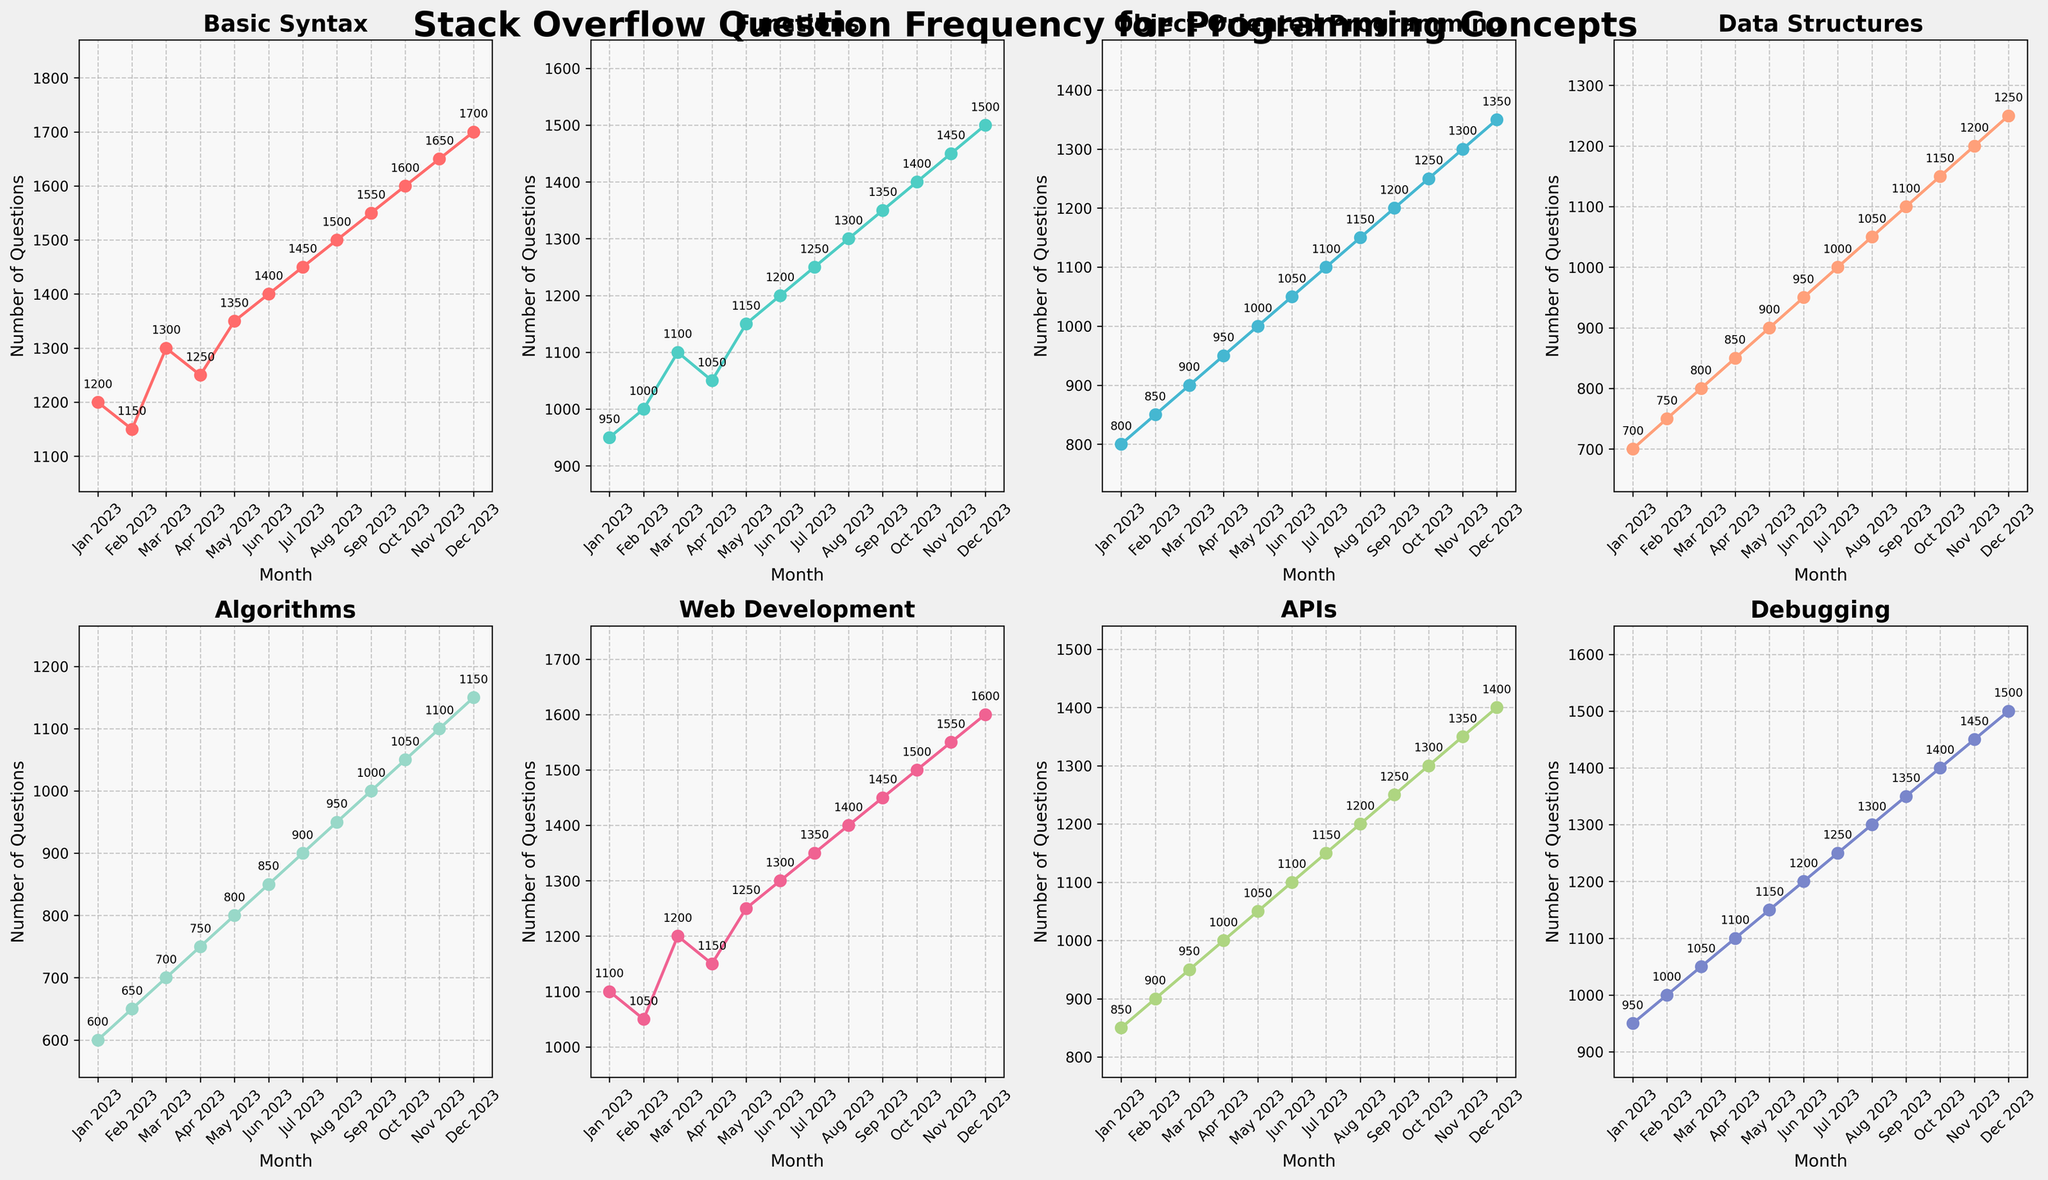What is the total number of questions for 'Web Development' in the first half of 2023? Sum the number of questions for 'Web Development' from Jan 2023 to Jun 2023: 1100 + 1050 + 1200 + 1150 + 1250 + 1300. The total is 7150.
Answer: 7150 In which month did 'Basic Syntax' receive the highest number of questions? The highest number of questions for 'Basic Syntax' is 1700 in December 2023.
Answer: December 2023 Compare the number of questions for 'Algorithms' in April and October 2023. Which month had more questions? 'Algorithms' had 750 questions in April and 1050 questions in October. October had more questions.
Answer: October What is the average number of questions per month for 'Functions' in the second half of 2023? Sum the number of questions for 'Functions' from Jul 2023 to Dec 2023: 1250 + 1300 + 1350 + 1400 + 1450 + 1500. The total is 8250. Divide by the number of months (6) to get the average: 8250/6 = 1375.
Answer: 1375 For 'Data Structures', what is the difference in the number of questions between the peak month and the lowest month in 2023? The highest number of questions for 'Data Structures' is 1250 in December and the lowest is 700 in January. The difference is 1250 - 700 = 550.
Answer: 550 What is the median number of monthly questions for 'Object-Oriented Programming' in 2023? List the monthly questions for 'Object-Oriented Programming': 800, 850, 900, 950, 1000, 1050, 1150, 1200, 1250, 1300, 1350. The median is the middle value in this sorted list, so the 6th value, which is 1050.
Answer: 1050 Look at the color-coded lines and identify which concept is represented by the green line. The green line corresponds to 'Functions'.
Answer: Functions What is the percentage increase in 'APIs' from January to December 2023? The number of questions in January for 'APIs' was 850 and in December it was 1400. The percentage increase: ((1400 - 850) / 850) * 100 = 64.71%.
Answer: 64.71% 